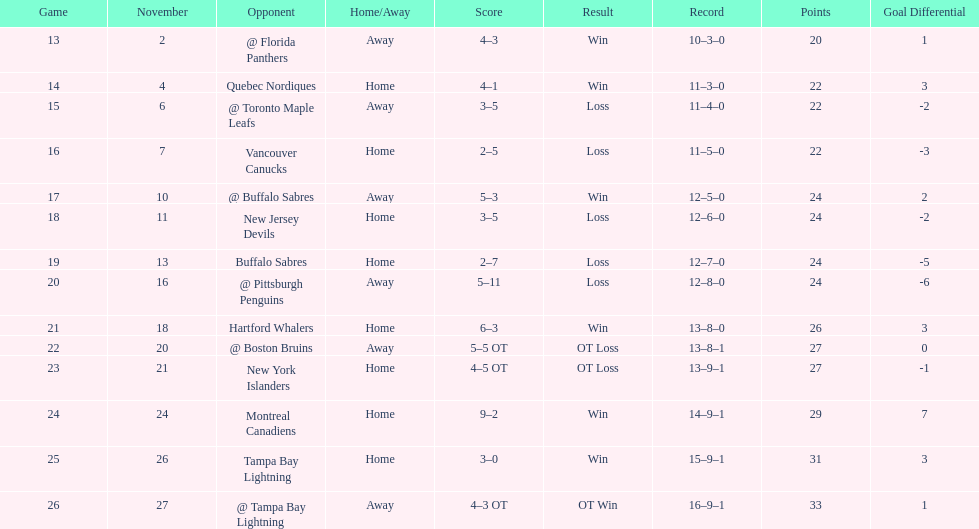The 1993-1994 flyers missed the playoffs again. how many consecutive seasons up until 93-94 did the flyers miss the playoffs? 5. 